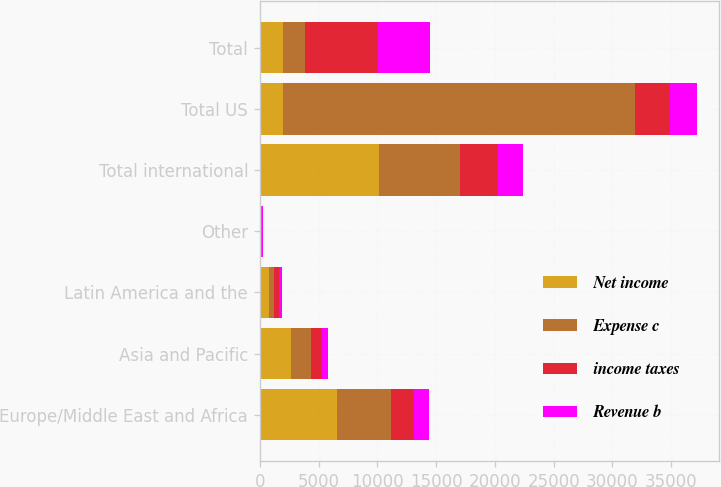Convert chart to OTSL. <chart><loc_0><loc_0><loc_500><loc_500><stacked_bar_chart><ecel><fcel>Europe/Middle East and Africa<fcel>Asia and Pacific<fcel>Latin America and the<fcel>Other<fcel>Total international<fcel>Total US<fcel>Total<nl><fcel>Net income<fcel>6566<fcel>2631<fcel>816<fcel>112<fcel>10125<fcel>1931<fcel>1931<nl><fcel>Expense c<fcel>4635<fcel>1766<fcel>411<fcel>77<fcel>6889<fcel>30014<fcel>1931<nl><fcel>income taxes<fcel>1931<fcel>865<fcel>405<fcel>35<fcel>3236<fcel>2958<fcel>6194<nl><fcel>Revenue b<fcel>1305<fcel>547<fcel>255<fcel>25<fcel>2132<fcel>2334<fcel>4466<nl></chart> 